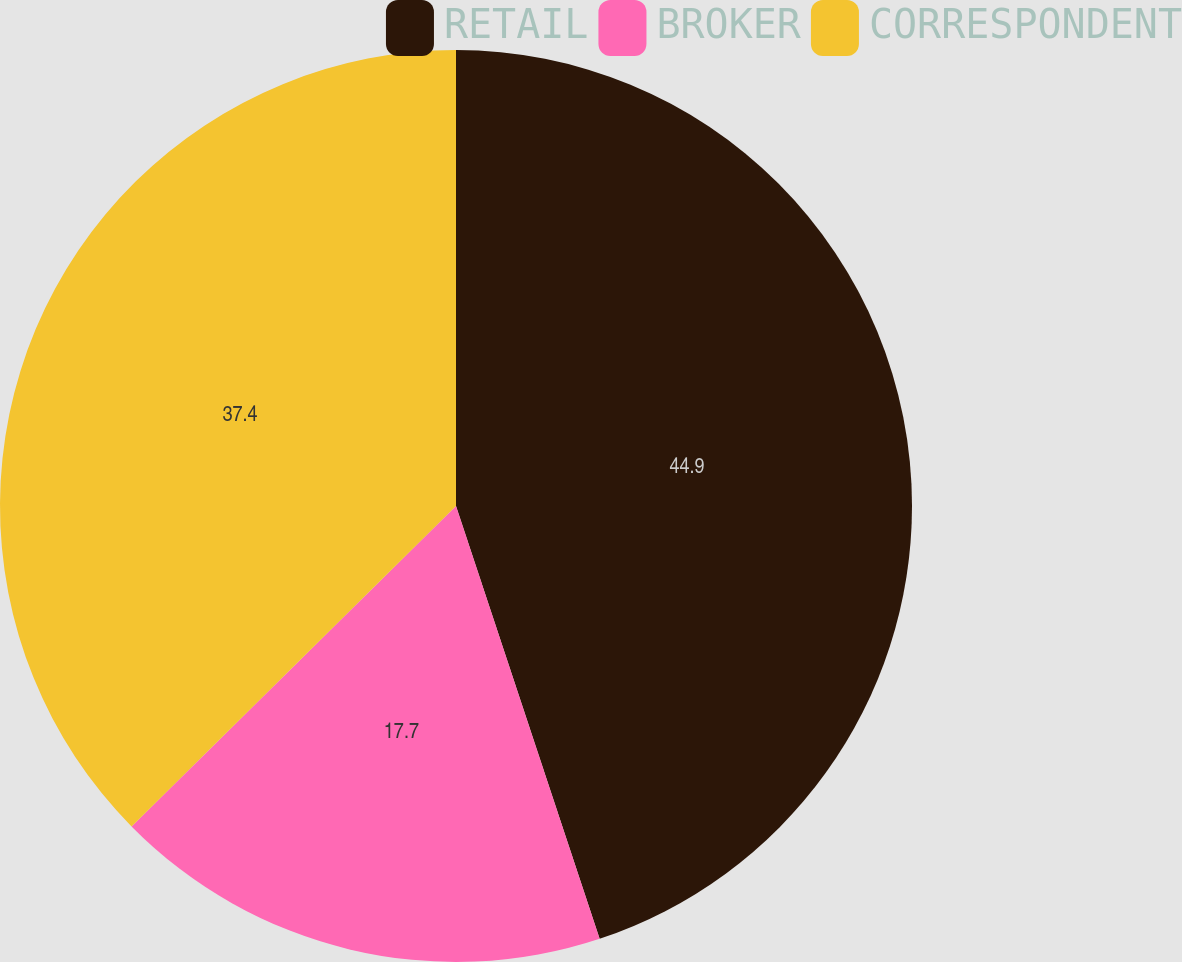<chart> <loc_0><loc_0><loc_500><loc_500><pie_chart><fcel>RETAIL<fcel>BROKER<fcel>CORRESPONDENT<nl><fcel>44.9%<fcel>17.7%<fcel>37.4%<nl></chart> 